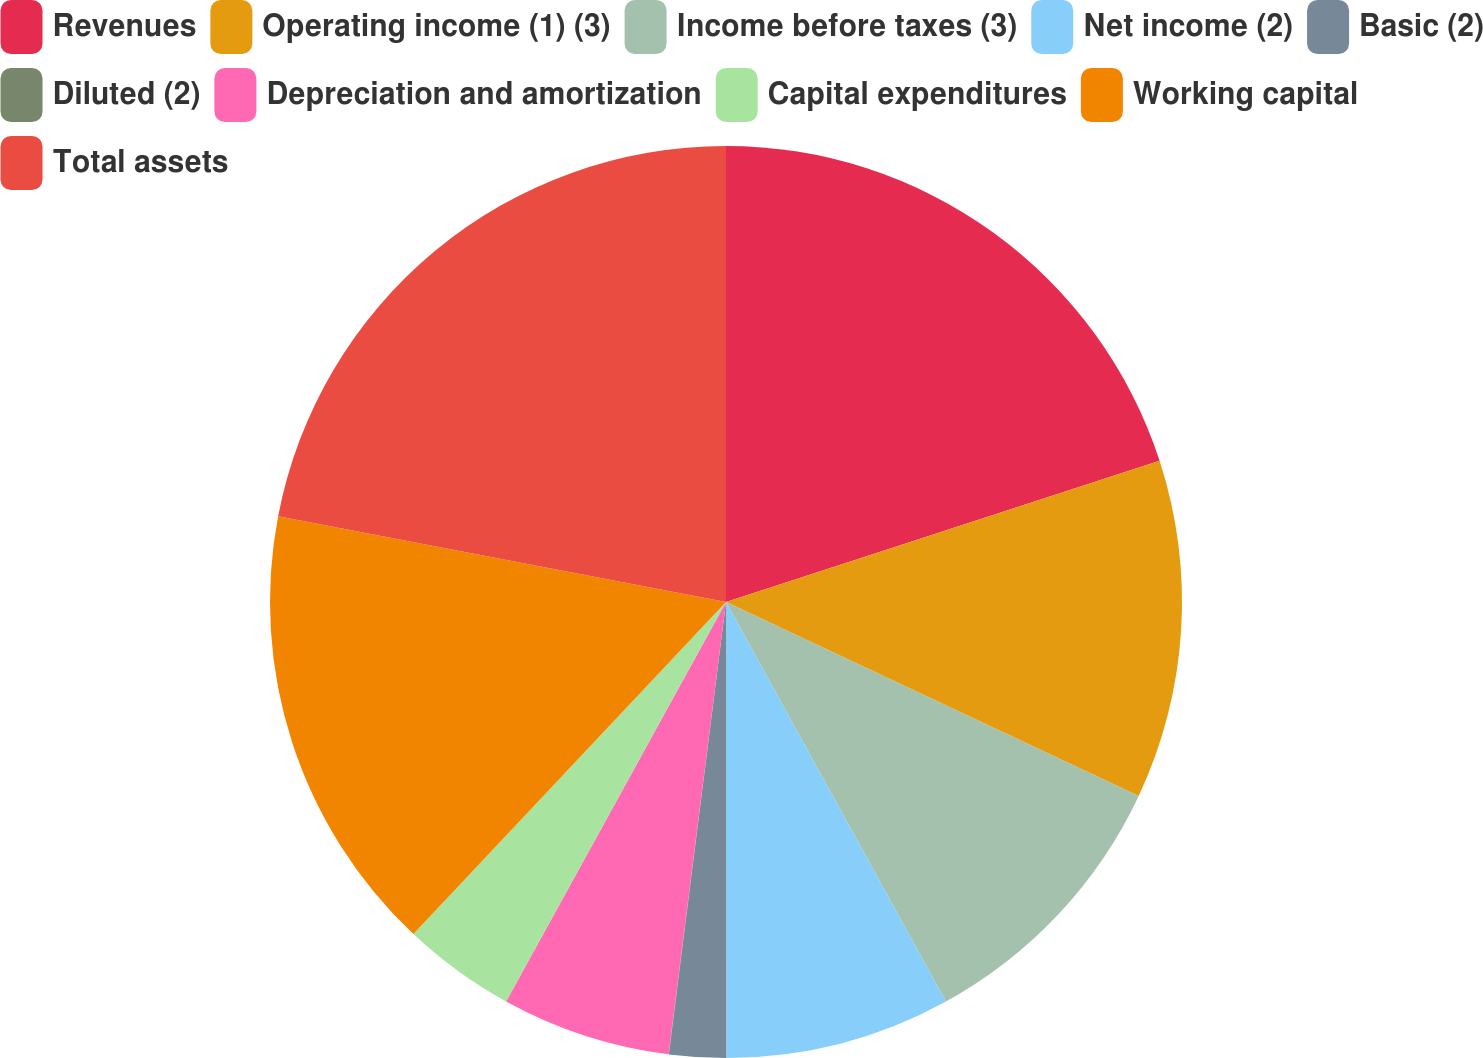Convert chart. <chart><loc_0><loc_0><loc_500><loc_500><pie_chart><fcel>Revenues<fcel>Operating income (1) (3)<fcel>Income before taxes (3)<fcel>Net income (2)<fcel>Basic (2)<fcel>Diluted (2)<fcel>Depreciation and amortization<fcel>Capital expenditures<fcel>Working capital<fcel>Total assets<nl><fcel>19.99%<fcel>12.0%<fcel>10.0%<fcel>8.0%<fcel>2.01%<fcel>0.01%<fcel>6.0%<fcel>4.01%<fcel>15.99%<fcel>21.99%<nl></chart> 